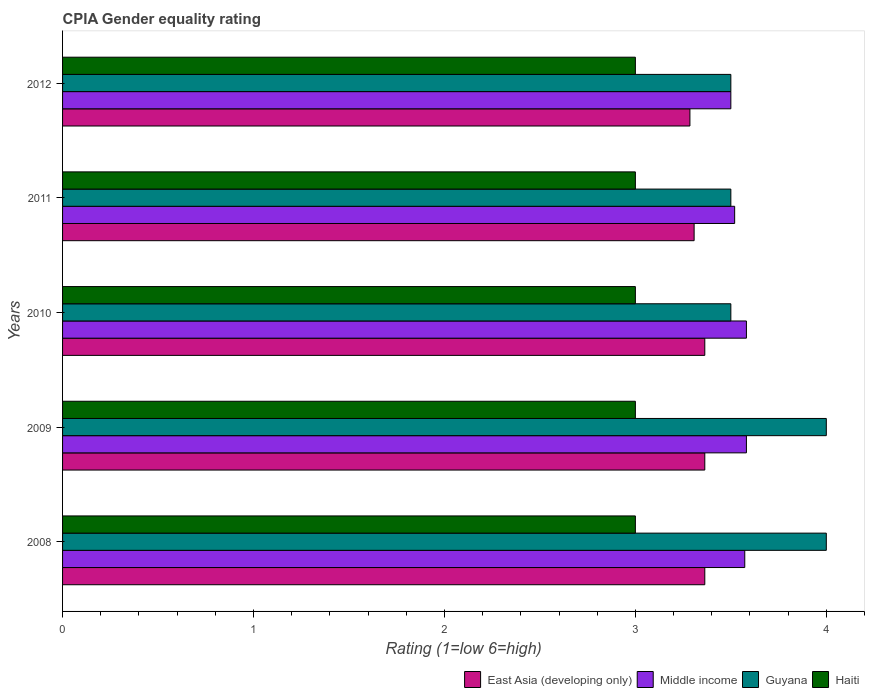How many bars are there on the 1st tick from the top?
Your response must be concise. 4. How many bars are there on the 3rd tick from the bottom?
Your response must be concise. 4. What is the CPIA rating in East Asia (developing only) in 2008?
Your answer should be compact. 3.36. Across all years, what is the maximum CPIA rating in Haiti?
Provide a short and direct response. 3. Across all years, what is the minimum CPIA rating in Haiti?
Offer a terse response. 3. What is the total CPIA rating in Haiti in the graph?
Your answer should be compact. 15. What is the difference between the CPIA rating in East Asia (developing only) in 2011 and that in 2012?
Ensure brevity in your answer.  0.02. What is the difference between the CPIA rating in Middle income in 2010 and the CPIA rating in East Asia (developing only) in 2011?
Offer a terse response. 0.27. What is the average CPIA rating in Haiti per year?
Your answer should be compact. 3. In the year 2011, what is the difference between the CPIA rating in Haiti and CPIA rating in Middle income?
Offer a terse response. -0.52. In how many years, is the CPIA rating in Middle income greater than 1.8 ?
Provide a short and direct response. 5. What is the ratio of the CPIA rating in Middle income in 2010 to that in 2012?
Your answer should be compact. 1.02. Is the CPIA rating in Guyana in 2008 less than that in 2011?
Ensure brevity in your answer.  No. What is the difference between the highest and the second highest CPIA rating in Guyana?
Keep it short and to the point. 0. Is it the case that in every year, the sum of the CPIA rating in Haiti and CPIA rating in Middle income is greater than the sum of CPIA rating in Guyana and CPIA rating in East Asia (developing only)?
Provide a succinct answer. No. What does the 2nd bar from the top in 2008 represents?
Your response must be concise. Guyana. What does the 1st bar from the bottom in 2008 represents?
Offer a terse response. East Asia (developing only). How many bars are there?
Give a very brief answer. 20. Does the graph contain any zero values?
Provide a short and direct response. No. Where does the legend appear in the graph?
Your answer should be compact. Bottom right. What is the title of the graph?
Offer a terse response. CPIA Gender equality rating. What is the label or title of the X-axis?
Keep it short and to the point. Rating (1=low 6=high). What is the label or title of the Y-axis?
Provide a succinct answer. Years. What is the Rating (1=low 6=high) of East Asia (developing only) in 2008?
Ensure brevity in your answer.  3.36. What is the Rating (1=low 6=high) of Middle income in 2008?
Provide a succinct answer. 3.57. What is the Rating (1=low 6=high) in Guyana in 2008?
Make the answer very short. 4. What is the Rating (1=low 6=high) in East Asia (developing only) in 2009?
Make the answer very short. 3.36. What is the Rating (1=low 6=high) of Middle income in 2009?
Ensure brevity in your answer.  3.58. What is the Rating (1=low 6=high) in East Asia (developing only) in 2010?
Your answer should be compact. 3.36. What is the Rating (1=low 6=high) of Middle income in 2010?
Offer a very short reply. 3.58. What is the Rating (1=low 6=high) in Haiti in 2010?
Provide a short and direct response. 3. What is the Rating (1=low 6=high) in East Asia (developing only) in 2011?
Ensure brevity in your answer.  3.31. What is the Rating (1=low 6=high) in Middle income in 2011?
Ensure brevity in your answer.  3.52. What is the Rating (1=low 6=high) of Guyana in 2011?
Your answer should be compact. 3.5. What is the Rating (1=low 6=high) in East Asia (developing only) in 2012?
Offer a terse response. 3.29. What is the Rating (1=low 6=high) of Middle income in 2012?
Your answer should be very brief. 3.5. What is the Rating (1=low 6=high) of Guyana in 2012?
Offer a very short reply. 3.5. Across all years, what is the maximum Rating (1=low 6=high) in East Asia (developing only)?
Ensure brevity in your answer.  3.36. Across all years, what is the maximum Rating (1=low 6=high) in Middle income?
Make the answer very short. 3.58. Across all years, what is the maximum Rating (1=low 6=high) of Guyana?
Keep it short and to the point. 4. Across all years, what is the maximum Rating (1=low 6=high) in Haiti?
Ensure brevity in your answer.  3. Across all years, what is the minimum Rating (1=low 6=high) in East Asia (developing only)?
Provide a short and direct response. 3.29. Across all years, what is the minimum Rating (1=low 6=high) of Haiti?
Your response must be concise. 3. What is the total Rating (1=low 6=high) in East Asia (developing only) in the graph?
Ensure brevity in your answer.  16.68. What is the total Rating (1=low 6=high) in Middle income in the graph?
Provide a succinct answer. 17.76. What is the difference between the Rating (1=low 6=high) in Middle income in 2008 and that in 2009?
Ensure brevity in your answer.  -0.01. What is the difference between the Rating (1=low 6=high) of Guyana in 2008 and that in 2009?
Your answer should be very brief. 0. What is the difference between the Rating (1=low 6=high) of Haiti in 2008 and that in 2009?
Give a very brief answer. 0. What is the difference between the Rating (1=low 6=high) in Middle income in 2008 and that in 2010?
Give a very brief answer. -0.01. What is the difference between the Rating (1=low 6=high) in Guyana in 2008 and that in 2010?
Provide a succinct answer. 0.5. What is the difference between the Rating (1=low 6=high) of East Asia (developing only) in 2008 and that in 2011?
Provide a short and direct response. 0.06. What is the difference between the Rating (1=low 6=high) in Middle income in 2008 and that in 2011?
Ensure brevity in your answer.  0.05. What is the difference between the Rating (1=low 6=high) in East Asia (developing only) in 2008 and that in 2012?
Your response must be concise. 0.08. What is the difference between the Rating (1=low 6=high) of Middle income in 2008 and that in 2012?
Give a very brief answer. 0.07. What is the difference between the Rating (1=low 6=high) of Guyana in 2008 and that in 2012?
Your answer should be compact. 0.5. What is the difference between the Rating (1=low 6=high) of Guyana in 2009 and that in 2010?
Make the answer very short. 0.5. What is the difference between the Rating (1=low 6=high) in Haiti in 2009 and that in 2010?
Provide a short and direct response. 0. What is the difference between the Rating (1=low 6=high) in East Asia (developing only) in 2009 and that in 2011?
Ensure brevity in your answer.  0.06. What is the difference between the Rating (1=low 6=high) in Middle income in 2009 and that in 2011?
Provide a succinct answer. 0.06. What is the difference between the Rating (1=low 6=high) in Guyana in 2009 and that in 2011?
Your answer should be compact. 0.5. What is the difference between the Rating (1=low 6=high) of Haiti in 2009 and that in 2011?
Provide a short and direct response. 0. What is the difference between the Rating (1=low 6=high) of East Asia (developing only) in 2009 and that in 2012?
Keep it short and to the point. 0.08. What is the difference between the Rating (1=low 6=high) in Middle income in 2009 and that in 2012?
Keep it short and to the point. 0.08. What is the difference between the Rating (1=low 6=high) of Guyana in 2009 and that in 2012?
Ensure brevity in your answer.  0.5. What is the difference between the Rating (1=low 6=high) in East Asia (developing only) in 2010 and that in 2011?
Provide a short and direct response. 0.06. What is the difference between the Rating (1=low 6=high) of Middle income in 2010 and that in 2011?
Your answer should be compact. 0.06. What is the difference between the Rating (1=low 6=high) of Guyana in 2010 and that in 2011?
Give a very brief answer. 0. What is the difference between the Rating (1=low 6=high) in Haiti in 2010 and that in 2011?
Provide a short and direct response. 0. What is the difference between the Rating (1=low 6=high) of East Asia (developing only) in 2010 and that in 2012?
Offer a terse response. 0.08. What is the difference between the Rating (1=low 6=high) in Middle income in 2010 and that in 2012?
Your response must be concise. 0.08. What is the difference between the Rating (1=low 6=high) of Guyana in 2010 and that in 2012?
Give a very brief answer. 0. What is the difference between the Rating (1=low 6=high) in East Asia (developing only) in 2011 and that in 2012?
Your response must be concise. 0.02. What is the difference between the Rating (1=low 6=high) of Middle income in 2011 and that in 2012?
Keep it short and to the point. 0.02. What is the difference between the Rating (1=low 6=high) in Guyana in 2011 and that in 2012?
Give a very brief answer. 0. What is the difference between the Rating (1=low 6=high) of East Asia (developing only) in 2008 and the Rating (1=low 6=high) of Middle income in 2009?
Give a very brief answer. -0.22. What is the difference between the Rating (1=low 6=high) in East Asia (developing only) in 2008 and the Rating (1=low 6=high) in Guyana in 2009?
Give a very brief answer. -0.64. What is the difference between the Rating (1=low 6=high) in East Asia (developing only) in 2008 and the Rating (1=low 6=high) in Haiti in 2009?
Your response must be concise. 0.36. What is the difference between the Rating (1=low 6=high) of Middle income in 2008 and the Rating (1=low 6=high) of Guyana in 2009?
Your answer should be compact. -0.43. What is the difference between the Rating (1=low 6=high) of Middle income in 2008 and the Rating (1=low 6=high) of Haiti in 2009?
Provide a succinct answer. 0.57. What is the difference between the Rating (1=low 6=high) in East Asia (developing only) in 2008 and the Rating (1=low 6=high) in Middle income in 2010?
Keep it short and to the point. -0.22. What is the difference between the Rating (1=low 6=high) in East Asia (developing only) in 2008 and the Rating (1=low 6=high) in Guyana in 2010?
Give a very brief answer. -0.14. What is the difference between the Rating (1=low 6=high) in East Asia (developing only) in 2008 and the Rating (1=low 6=high) in Haiti in 2010?
Offer a terse response. 0.36. What is the difference between the Rating (1=low 6=high) of Middle income in 2008 and the Rating (1=low 6=high) of Guyana in 2010?
Ensure brevity in your answer.  0.07. What is the difference between the Rating (1=low 6=high) of Middle income in 2008 and the Rating (1=low 6=high) of Haiti in 2010?
Make the answer very short. 0.57. What is the difference between the Rating (1=low 6=high) in East Asia (developing only) in 2008 and the Rating (1=low 6=high) in Middle income in 2011?
Your answer should be very brief. -0.16. What is the difference between the Rating (1=low 6=high) in East Asia (developing only) in 2008 and the Rating (1=low 6=high) in Guyana in 2011?
Keep it short and to the point. -0.14. What is the difference between the Rating (1=low 6=high) of East Asia (developing only) in 2008 and the Rating (1=low 6=high) of Haiti in 2011?
Ensure brevity in your answer.  0.36. What is the difference between the Rating (1=low 6=high) of Middle income in 2008 and the Rating (1=low 6=high) of Guyana in 2011?
Your answer should be compact. 0.07. What is the difference between the Rating (1=low 6=high) in Middle income in 2008 and the Rating (1=low 6=high) in Haiti in 2011?
Your answer should be compact. 0.57. What is the difference between the Rating (1=low 6=high) in Guyana in 2008 and the Rating (1=low 6=high) in Haiti in 2011?
Give a very brief answer. 1. What is the difference between the Rating (1=low 6=high) in East Asia (developing only) in 2008 and the Rating (1=low 6=high) in Middle income in 2012?
Make the answer very short. -0.14. What is the difference between the Rating (1=low 6=high) of East Asia (developing only) in 2008 and the Rating (1=low 6=high) of Guyana in 2012?
Provide a short and direct response. -0.14. What is the difference between the Rating (1=low 6=high) of East Asia (developing only) in 2008 and the Rating (1=low 6=high) of Haiti in 2012?
Ensure brevity in your answer.  0.36. What is the difference between the Rating (1=low 6=high) of Middle income in 2008 and the Rating (1=low 6=high) of Guyana in 2012?
Offer a very short reply. 0.07. What is the difference between the Rating (1=low 6=high) in Middle income in 2008 and the Rating (1=low 6=high) in Haiti in 2012?
Make the answer very short. 0.57. What is the difference between the Rating (1=low 6=high) of Guyana in 2008 and the Rating (1=low 6=high) of Haiti in 2012?
Keep it short and to the point. 1. What is the difference between the Rating (1=low 6=high) in East Asia (developing only) in 2009 and the Rating (1=low 6=high) in Middle income in 2010?
Provide a short and direct response. -0.22. What is the difference between the Rating (1=low 6=high) in East Asia (developing only) in 2009 and the Rating (1=low 6=high) in Guyana in 2010?
Make the answer very short. -0.14. What is the difference between the Rating (1=low 6=high) of East Asia (developing only) in 2009 and the Rating (1=low 6=high) of Haiti in 2010?
Keep it short and to the point. 0.36. What is the difference between the Rating (1=low 6=high) of Middle income in 2009 and the Rating (1=low 6=high) of Guyana in 2010?
Offer a terse response. 0.08. What is the difference between the Rating (1=low 6=high) of Middle income in 2009 and the Rating (1=low 6=high) of Haiti in 2010?
Make the answer very short. 0.58. What is the difference between the Rating (1=low 6=high) in East Asia (developing only) in 2009 and the Rating (1=low 6=high) in Middle income in 2011?
Give a very brief answer. -0.16. What is the difference between the Rating (1=low 6=high) of East Asia (developing only) in 2009 and the Rating (1=low 6=high) of Guyana in 2011?
Provide a short and direct response. -0.14. What is the difference between the Rating (1=low 6=high) in East Asia (developing only) in 2009 and the Rating (1=low 6=high) in Haiti in 2011?
Provide a succinct answer. 0.36. What is the difference between the Rating (1=low 6=high) in Middle income in 2009 and the Rating (1=low 6=high) in Guyana in 2011?
Your answer should be compact. 0.08. What is the difference between the Rating (1=low 6=high) in Middle income in 2009 and the Rating (1=low 6=high) in Haiti in 2011?
Your answer should be compact. 0.58. What is the difference between the Rating (1=low 6=high) in Guyana in 2009 and the Rating (1=low 6=high) in Haiti in 2011?
Offer a terse response. 1. What is the difference between the Rating (1=low 6=high) in East Asia (developing only) in 2009 and the Rating (1=low 6=high) in Middle income in 2012?
Offer a very short reply. -0.14. What is the difference between the Rating (1=low 6=high) in East Asia (developing only) in 2009 and the Rating (1=low 6=high) in Guyana in 2012?
Your answer should be compact. -0.14. What is the difference between the Rating (1=low 6=high) of East Asia (developing only) in 2009 and the Rating (1=low 6=high) of Haiti in 2012?
Offer a terse response. 0.36. What is the difference between the Rating (1=low 6=high) in Middle income in 2009 and the Rating (1=low 6=high) in Guyana in 2012?
Your response must be concise. 0.08. What is the difference between the Rating (1=low 6=high) of Middle income in 2009 and the Rating (1=low 6=high) of Haiti in 2012?
Offer a very short reply. 0.58. What is the difference between the Rating (1=low 6=high) of East Asia (developing only) in 2010 and the Rating (1=low 6=high) of Middle income in 2011?
Your answer should be very brief. -0.16. What is the difference between the Rating (1=low 6=high) in East Asia (developing only) in 2010 and the Rating (1=low 6=high) in Guyana in 2011?
Your answer should be compact. -0.14. What is the difference between the Rating (1=low 6=high) in East Asia (developing only) in 2010 and the Rating (1=low 6=high) in Haiti in 2011?
Keep it short and to the point. 0.36. What is the difference between the Rating (1=low 6=high) of Middle income in 2010 and the Rating (1=low 6=high) of Guyana in 2011?
Provide a succinct answer. 0.08. What is the difference between the Rating (1=low 6=high) in Middle income in 2010 and the Rating (1=low 6=high) in Haiti in 2011?
Your answer should be very brief. 0.58. What is the difference between the Rating (1=low 6=high) of Guyana in 2010 and the Rating (1=low 6=high) of Haiti in 2011?
Provide a succinct answer. 0.5. What is the difference between the Rating (1=low 6=high) of East Asia (developing only) in 2010 and the Rating (1=low 6=high) of Middle income in 2012?
Ensure brevity in your answer.  -0.14. What is the difference between the Rating (1=low 6=high) of East Asia (developing only) in 2010 and the Rating (1=low 6=high) of Guyana in 2012?
Keep it short and to the point. -0.14. What is the difference between the Rating (1=low 6=high) of East Asia (developing only) in 2010 and the Rating (1=low 6=high) of Haiti in 2012?
Provide a short and direct response. 0.36. What is the difference between the Rating (1=low 6=high) in Middle income in 2010 and the Rating (1=low 6=high) in Guyana in 2012?
Offer a terse response. 0.08. What is the difference between the Rating (1=low 6=high) in Middle income in 2010 and the Rating (1=low 6=high) in Haiti in 2012?
Your answer should be very brief. 0.58. What is the difference between the Rating (1=low 6=high) in Guyana in 2010 and the Rating (1=low 6=high) in Haiti in 2012?
Provide a succinct answer. 0.5. What is the difference between the Rating (1=low 6=high) of East Asia (developing only) in 2011 and the Rating (1=low 6=high) of Middle income in 2012?
Provide a succinct answer. -0.19. What is the difference between the Rating (1=low 6=high) of East Asia (developing only) in 2011 and the Rating (1=low 6=high) of Guyana in 2012?
Offer a terse response. -0.19. What is the difference between the Rating (1=low 6=high) of East Asia (developing only) in 2011 and the Rating (1=low 6=high) of Haiti in 2012?
Offer a very short reply. 0.31. What is the difference between the Rating (1=low 6=high) in Middle income in 2011 and the Rating (1=low 6=high) in Guyana in 2012?
Your answer should be compact. 0.02. What is the difference between the Rating (1=low 6=high) in Middle income in 2011 and the Rating (1=low 6=high) in Haiti in 2012?
Your answer should be compact. 0.52. What is the average Rating (1=low 6=high) in East Asia (developing only) per year?
Ensure brevity in your answer.  3.34. What is the average Rating (1=low 6=high) in Middle income per year?
Provide a short and direct response. 3.55. What is the average Rating (1=low 6=high) of Guyana per year?
Offer a very short reply. 3.7. What is the average Rating (1=low 6=high) in Haiti per year?
Ensure brevity in your answer.  3. In the year 2008, what is the difference between the Rating (1=low 6=high) in East Asia (developing only) and Rating (1=low 6=high) in Middle income?
Make the answer very short. -0.21. In the year 2008, what is the difference between the Rating (1=low 6=high) in East Asia (developing only) and Rating (1=low 6=high) in Guyana?
Offer a very short reply. -0.64. In the year 2008, what is the difference between the Rating (1=low 6=high) of East Asia (developing only) and Rating (1=low 6=high) of Haiti?
Ensure brevity in your answer.  0.36. In the year 2008, what is the difference between the Rating (1=low 6=high) of Middle income and Rating (1=low 6=high) of Guyana?
Give a very brief answer. -0.43. In the year 2008, what is the difference between the Rating (1=low 6=high) of Middle income and Rating (1=low 6=high) of Haiti?
Offer a terse response. 0.57. In the year 2008, what is the difference between the Rating (1=low 6=high) in Guyana and Rating (1=low 6=high) in Haiti?
Provide a short and direct response. 1. In the year 2009, what is the difference between the Rating (1=low 6=high) of East Asia (developing only) and Rating (1=low 6=high) of Middle income?
Offer a terse response. -0.22. In the year 2009, what is the difference between the Rating (1=low 6=high) in East Asia (developing only) and Rating (1=low 6=high) in Guyana?
Your answer should be compact. -0.64. In the year 2009, what is the difference between the Rating (1=low 6=high) in East Asia (developing only) and Rating (1=low 6=high) in Haiti?
Ensure brevity in your answer.  0.36. In the year 2009, what is the difference between the Rating (1=low 6=high) in Middle income and Rating (1=low 6=high) in Guyana?
Make the answer very short. -0.42. In the year 2009, what is the difference between the Rating (1=low 6=high) in Middle income and Rating (1=low 6=high) in Haiti?
Give a very brief answer. 0.58. In the year 2009, what is the difference between the Rating (1=low 6=high) in Guyana and Rating (1=low 6=high) in Haiti?
Provide a short and direct response. 1. In the year 2010, what is the difference between the Rating (1=low 6=high) of East Asia (developing only) and Rating (1=low 6=high) of Middle income?
Keep it short and to the point. -0.22. In the year 2010, what is the difference between the Rating (1=low 6=high) of East Asia (developing only) and Rating (1=low 6=high) of Guyana?
Your answer should be very brief. -0.14. In the year 2010, what is the difference between the Rating (1=low 6=high) of East Asia (developing only) and Rating (1=low 6=high) of Haiti?
Offer a very short reply. 0.36. In the year 2010, what is the difference between the Rating (1=low 6=high) in Middle income and Rating (1=low 6=high) in Guyana?
Offer a very short reply. 0.08. In the year 2010, what is the difference between the Rating (1=low 6=high) in Middle income and Rating (1=low 6=high) in Haiti?
Provide a short and direct response. 0.58. In the year 2010, what is the difference between the Rating (1=low 6=high) in Guyana and Rating (1=low 6=high) in Haiti?
Your answer should be compact. 0.5. In the year 2011, what is the difference between the Rating (1=low 6=high) of East Asia (developing only) and Rating (1=low 6=high) of Middle income?
Provide a short and direct response. -0.21. In the year 2011, what is the difference between the Rating (1=low 6=high) in East Asia (developing only) and Rating (1=low 6=high) in Guyana?
Offer a very short reply. -0.19. In the year 2011, what is the difference between the Rating (1=low 6=high) in East Asia (developing only) and Rating (1=low 6=high) in Haiti?
Your answer should be very brief. 0.31. In the year 2011, what is the difference between the Rating (1=low 6=high) of Middle income and Rating (1=low 6=high) of Haiti?
Provide a succinct answer. 0.52. In the year 2011, what is the difference between the Rating (1=low 6=high) of Guyana and Rating (1=low 6=high) of Haiti?
Offer a very short reply. 0.5. In the year 2012, what is the difference between the Rating (1=low 6=high) in East Asia (developing only) and Rating (1=low 6=high) in Middle income?
Make the answer very short. -0.21. In the year 2012, what is the difference between the Rating (1=low 6=high) of East Asia (developing only) and Rating (1=low 6=high) of Guyana?
Make the answer very short. -0.21. In the year 2012, what is the difference between the Rating (1=low 6=high) of East Asia (developing only) and Rating (1=low 6=high) of Haiti?
Make the answer very short. 0.29. In the year 2012, what is the difference between the Rating (1=low 6=high) of Middle income and Rating (1=low 6=high) of Guyana?
Keep it short and to the point. 0. In the year 2012, what is the difference between the Rating (1=low 6=high) of Guyana and Rating (1=low 6=high) of Haiti?
Your response must be concise. 0.5. What is the ratio of the Rating (1=low 6=high) of Middle income in 2008 to that in 2009?
Ensure brevity in your answer.  1. What is the ratio of the Rating (1=low 6=high) in Guyana in 2008 to that in 2010?
Your answer should be very brief. 1.14. What is the ratio of the Rating (1=low 6=high) of East Asia (developing only) in 2008 to that in 2011?
Offer a terse response. 1.02. What is the ratio of the Rating (1=low 6=high) in Guyana in 2008 to that in 2011?
Your answer should be compact. 1.14. What is the ratio of the Rating (1=low 6=high) in East Asia (developing only) in 2008 to that in 2012?
Your response must be concise. 1.02. What is the ratio of the Rating (1=low 6=high) of Middle income in 2008 to that in 2012?
Offer a very short reply. 1.02. What is the ratio of the Rating (1=low 6=high) of Guyana in 2008 to that in 2012?
Your answer should be very brief. 1.14. What is the ratio of the Rating (1=low 6=high) in Haiti in 2008 to that in 2012?
Make the answer very short. 1. What is the ratio of the Rating (1=low 6=high) in East Asia (developing only) in 2009 to that in 2011?
Make the answer very short. 1.02. What is the ratio of the Rating (1=low 6=high) in Middle income in 2009 to that in 2011?
Offer a terse response. 1.02. What is the ratio of the Rating (1=low 6=high) in Haiti in 2009 to that in 2011?
Your response must be concise. 1. What is the ratio of the Rating (1=low 6=high) of East Asia (developing only) in 2009 to that in 2012?
Your answer should be very brief. 1.02. What is the ratio of the Rating (1=low 6=high) of Middle income in 2009 to that in 2012?
Provide a succinct answer. 1.02. What is the ratio of the Rating (1=low 6=high) in Guyana in 2009 to that in 2012?
Ensure brevity in your answer.  1.14. What is the ratio of the Rating (1=low 6=high) in East Asia (developing only) in 2010 to that in 2011?
Your answer should be compact. 1.02. What is the ratio of the Rating (1=low 6=high) of Middle income in 2010 to that in 2011?
Give a very brief answer. 1.02. What is the ratio of the Rating (1=low 6=high) in Guyana in 2010 to that in 2011?
Provide a short and direct response. 1. What is the ratio of the Rating (1=low 6=high) of East Asia (developing only) in 2010 to that in 2012?
Ensure brevity in your answer.  1.02. What is the ratio of the Rating (1=low 6=high) of Middle income in 2010 to that in 2012?
Keep it short and to the point. 1.02. What is the ratio of the Rating (1=low 6=high) of Guyana in 2010 to that in 2012?
Your answer should be compact. 1. What is the ratio of the Rating (1=low 6=high) in Haiti in 2010 to that in 2012?
Your response must be concise. 1. What is the ratio of the Rating (1=low 6=high) in East Asia (developing only) in 2011 to that in 2012?
Provide a succinct answer. 1.01. What is the ratio of the Rating (1=low 6=high) in Guyana in 2011 to that in 2012?
Make the answer very short. 1. What is the difference between the highest and the second highest Rating (1=low 6=high) of East Asia (developing only)?
Keep it short and to the point. 0. What is the difference between the highest and the second highest Rating (1=low 6=high) of Middle income?
Offer a terse response. 0. What is the difference between the highest and the lowest Rating (1=low 6=high) of East Asia (developing only)?
Give a very brief answer. 0.08. What is the difference between the highest and the lowest Rating (1=low 6=high) in Middle income?
Your response must be concise. 0.08. What is the difference between the highest and the lowest Rating (1=low 6=high) of Haiti?
Ensure brevity in your answer.  0. 